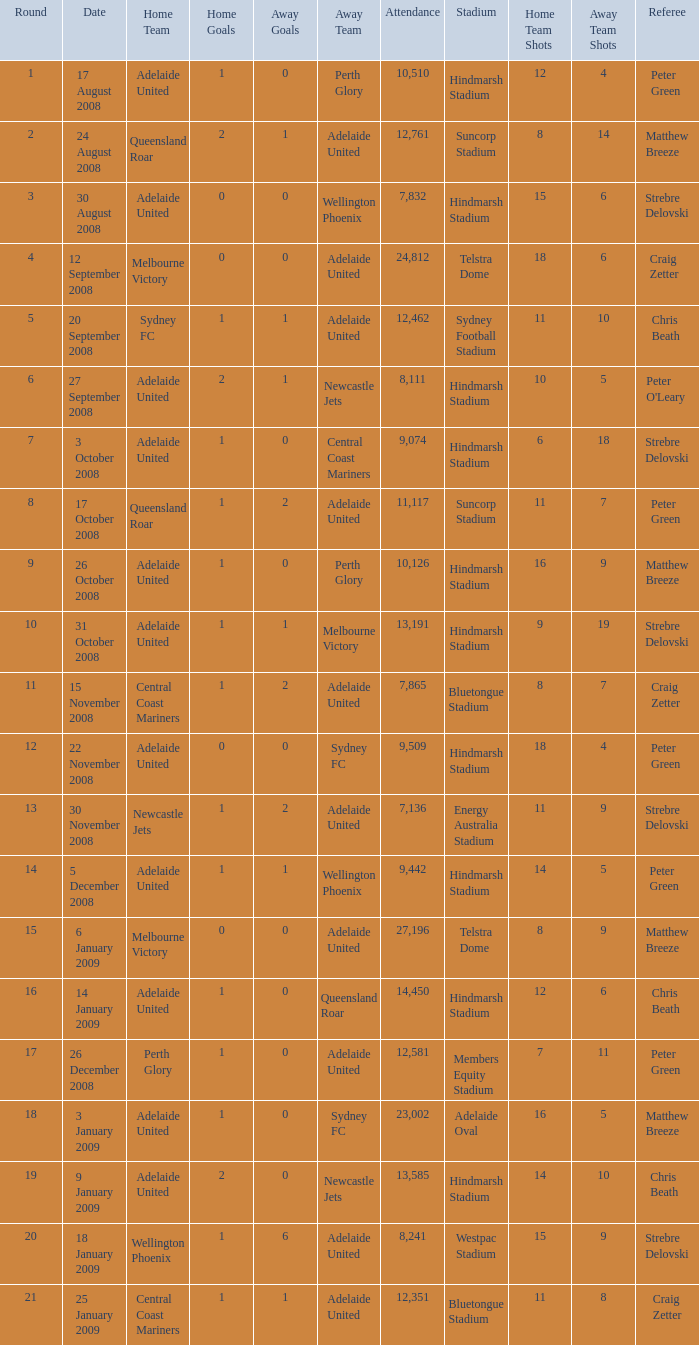Parse the full table. {'header': ['Round', 'Date', 'Home Team', 'Home Goals', 'Away Goals', 'Away Team', 'Attendance', 'Stadium', 'Home Team Shots', 'Away Team Shots', 'Referee'], 'rows': [['1', '17 August 2008', 'Adelaide United', '1', '0', 'Perth Glory', '10,510', 'Hindmarsh Stadium', '12', '4', 'Peter Green '], ['2', '24 August 2008', 'Queensland Roar', '2', '1', 'Adelaide United', '12,761', 'Suncorp Stadium', '8', '14', 'Matthew Breeze '], ['3', '30 August 2008', 'Adelaide United', '0', '0', 'Wellington Phoenix', '7,832', 'Hindmarsh Stadium', '15', '6', 'Strebre Delovski'], ['4', '12 September 2008', 'Melbourne Victory', '0', '0', 'Adelaide United', '24,812', 'Telstra Dome', '18', '6', 'Craig Zetter  '], ['5', '20 September 2008', 'Sydney FC', '1', '1', 'Adelaide United', '12,462', 'Sydney Football Stadium', '11', '10', 'Chris Beath '], ['6', '27 September 2008', 'Adelaide United', '2', '1', 'Newcastle Jets', '8,111', 'Hindmarsh Stadium', '10', '5', "Peter O'Leary "], ['7', '3 October 2008', 'Adelaide United', '1', '0', 'Central Coast Mariners', '9,074', 'Hindmarsh Stadium', '6', '18', 'Strebre Delovski '], ['8', '17 October 2008', 'Queensland Roar', '1', '2', 'Adelaide United', '11,117', 'Suncorp Stadium', '11', '7', 'Peter Green '], ['9', '26 October 2008', 'Adelaide United', '1', '0', 'Perth Glory', '10,126', 'Hindmarsh Stadium', '16', '9', 'Matthew Breeze '], ['10', '31 October 2008', 'Adelaide United', '1', '1', 'Melbourne Victory', '13,191', 'Hindmarsh Stadium', '9', '19', 'Strebre Delovski '], ['11', '15 November 2008', 'Central Coast Mariners', '1', '2', 'Adelaide United', '7,865', 'Bluetongue Stadium', '8', '7', 'Craig Zetter '], ['12', '22 November 2008', 'Adelaide United', '0', '0', 'Sydney FC', '9,509', 'Hindmarsh Stadium', '18', '4', 'Peter Green '], ['13', '30 November 2008', 'Newcastle Jets', '1', '2', 'Adelaide United', '7,136', 'Energy Australia Stadium', '11', '9', 'Strebre Delovski '], ['14', '5 December 2008', 'Adelaide United', '1', '1', 'Wellington Phoenix', '9,442', 'Hindmarsh Stadium', '14', '5', 'Peter Green  '], ['15', '6 January 2009', 'Melbourne Victory', '0', '0', 'Adelaide United', '27,196', 'Telstra Dome', '8', '9', 'Matthew Breeze '], ['16', '14 January 2009', 'Adelaide United', '1', '0', 'Queensland Roar', '14,450', 'Hindmarsh Stadium', '12', '6', 'Chris Beath '], ['17', '26 December 2008', 'Perth Glory', '1', '0', 'Adelaide United', '12,581', 'Members Equity Stadium', '7', '11', 'Peter Green '], ['18', '3 January 2009', 'Adelaide United', '1', '0', 'Sydney FC', '23,002', 'Adelaide Oval', '16', '5', 'Matthew Breeze '], ['19', '9 January 2009', 'Adelaide United', '2', '0', 'Newcastle Jets', '13,585', 'Hindmarsh Stadium', '14', '10', 'Chris Beath  '], ['20', '18 January 2009', 'Wellington Phoenix', '1', '6', 'Adelaide United', '8,241', 'Westpac Stadium', '15', '9', 'Strebre Delovski '], ['21', '25 January 2009', 'Central Coast Mariners', '1', '1', 'Adelaide United', '12,351', 'Bluetongue Stadium', '11', '8', 'Craig Zetter']]} What is the least round for the game played at Members Equity Stadium in from of 12,581 people? None. 